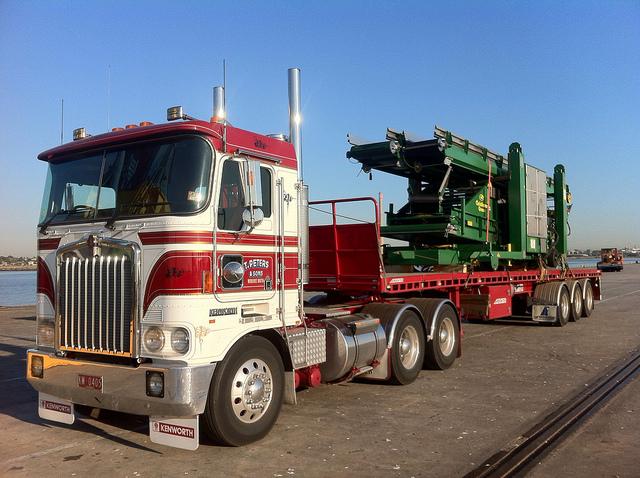Is this a fire truck?
Concise answer only. No. Is there a house?
Keep it brief. No. What color is the truck?
Answer briefly. Red and white. Is the truck old?
Quick response, please. No. What kind of truck is there?
Short answer required. Semi. Is this truck noisy?
Keep it brief. Yes. 